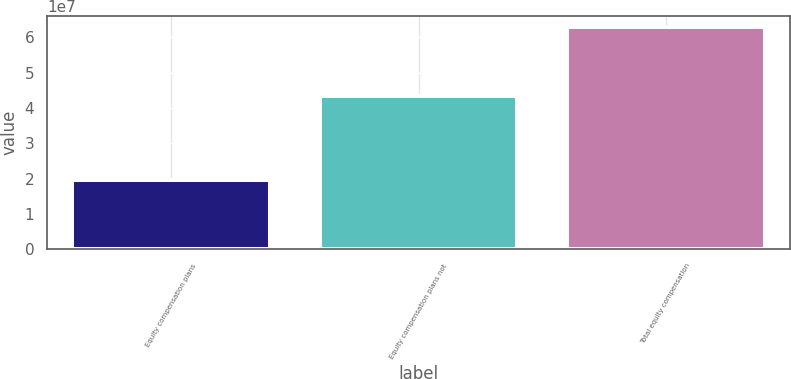Convert chart. <chart><loc_0><loc_0><loc_500><loc_500><bar_chart><fcel>Equity compensation plans<fcel>Equity compensation plans not<fcel>Total equity compensation<nl><fcel>1.95076e+07<fcel>4.33436e+07<fcel>6.28512e+07<nl></chart> 